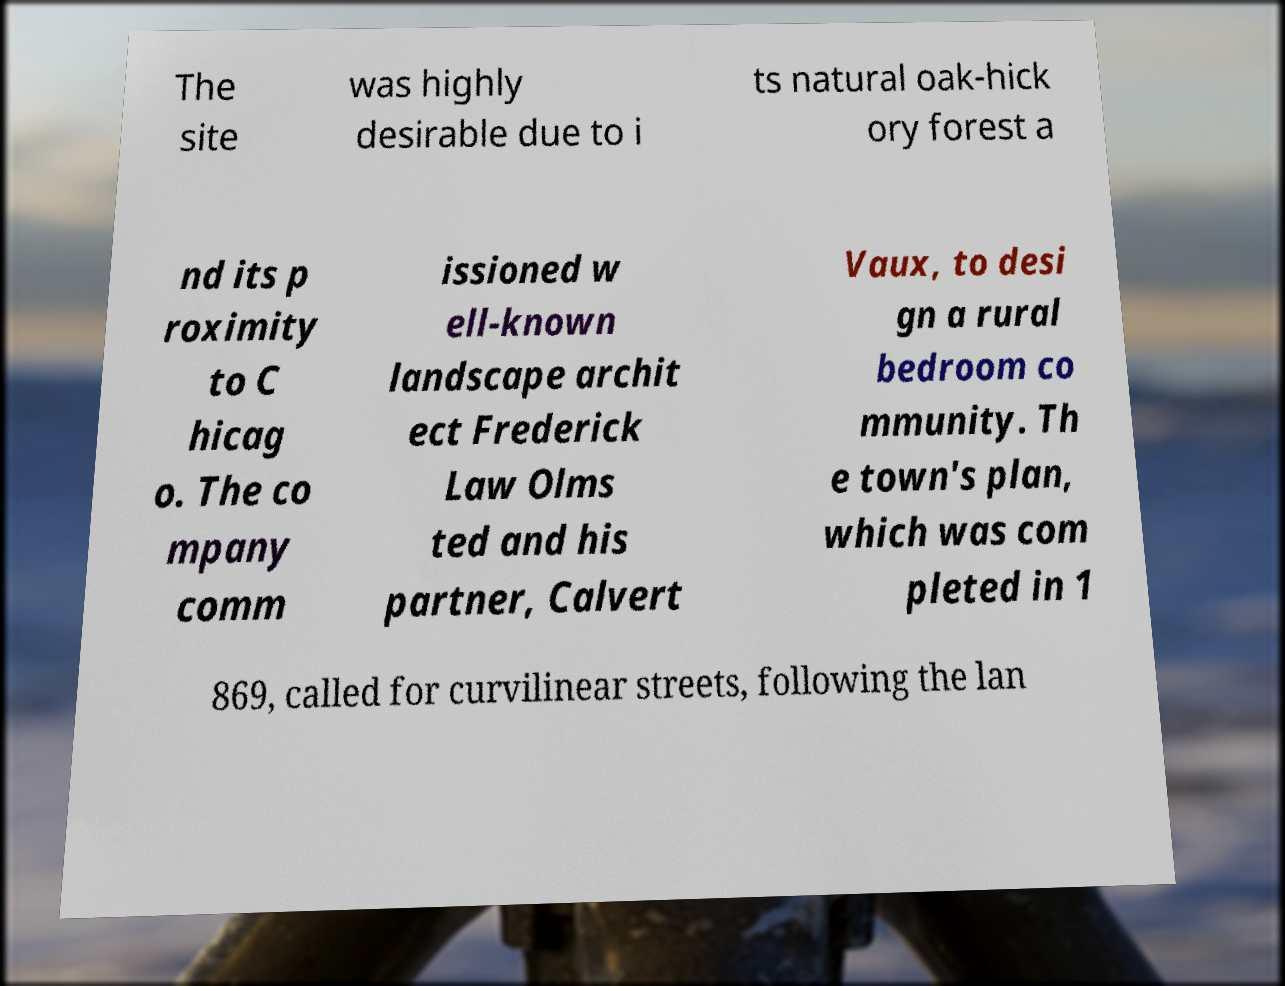I need the written content from this picture converted into text. Can you do that? The site was highly desirable due to i ts natural oak-hick ory forest a nd its p roximity to C hicag o. The co mpany comm issioned w ell-known landscape archit ect Frederick Law Olms ted and his partner, Calvert Vaux, to desi gn a rural bedroom co mmunity. Th e town's plan, which was com pleted in 1 869, called for curvilinear streets, following the lan 